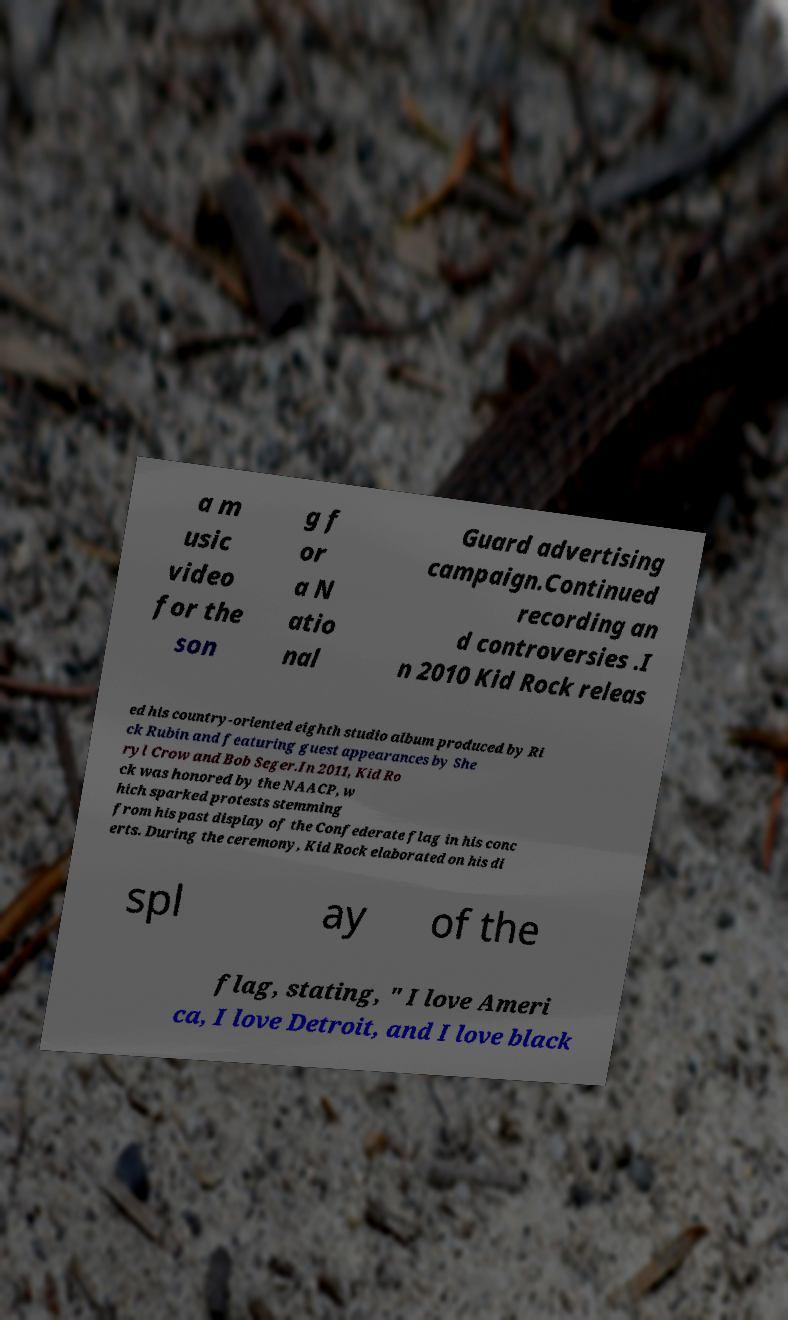Can you read and provide the text displayed in the image?This photo seems to have some interesting text. Can you extract and type it out for me? a m usic video for the son g f or a N atio nal Guard advertising campaign.Continued recording an d controversies .I n 2010 Kid Rock releas ed his country-oriented eighth studio album produced by Ri ck Rubin and featuring guest appearances by She ryl Crow and Bob Seger.In 2011, Kid Ro ck was honored by the NAACP, w hich sparked protests stemming from his past display of the Confederate flag in his conc erts. During the ceremony, Kid Rock elaborated on his di spl ay of the flag, stating, " I love Ameri ca, I love Detroit, and I love black 